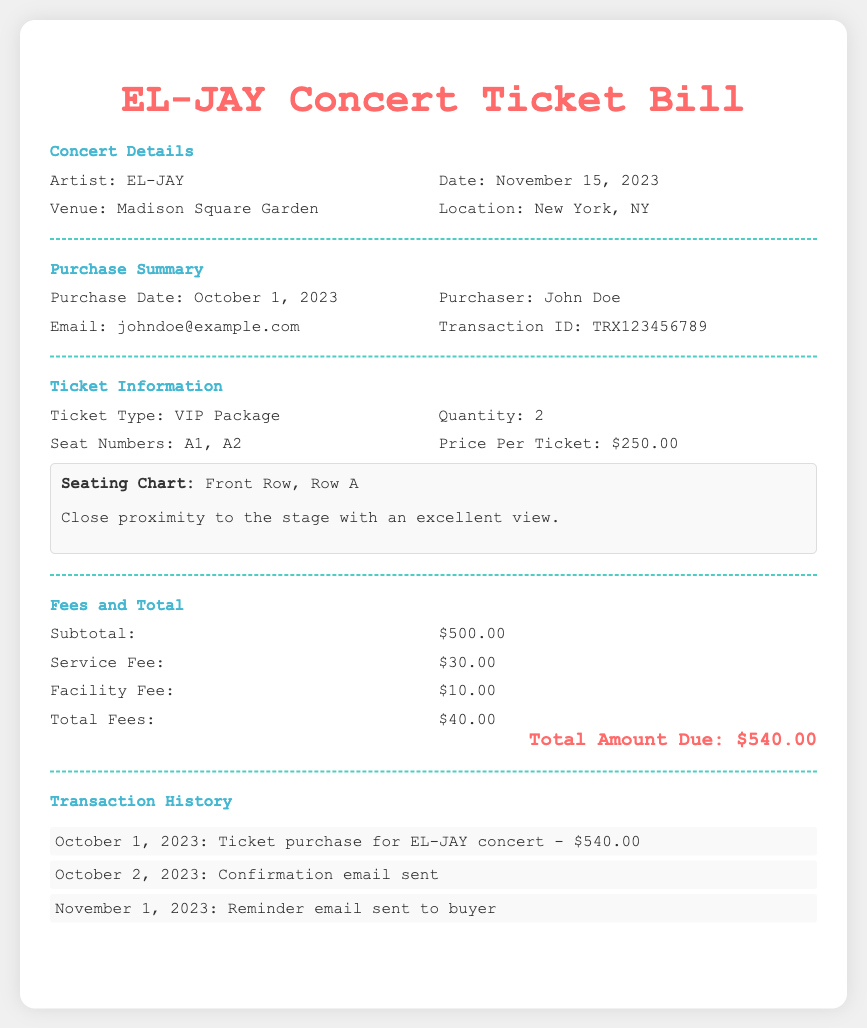What is the date of the concert? The concert date is provided in the document, which states November 15, 2023.
Answer: November 15, 2023 Who is the purchaser of the tickets? The document includes the purchaser's name as John Doe, highlighted in the Purchase Summary section.
Answer: John Doe How many tickets were purchased? The document specifies that the quantity of tickets purchased is 2 in the Ticket Information section.
Answer: 2 What is the total amount due? The total amount due is clearly listed at the bottom of the Fees and Total section, totaling $540.00.
Answer: $540.00 What are the seat numbers for the tickets? The seat numbers for the purchased tickets are listed in the Ticket Information section as A1 and A2.
Answer: A1, A2 What is the service fee included in the ticket purchase? The service fee amount is specifically mentioned in the Fees and Total section as $30.00.
Answer: $30.00 What is the transaction ID for the purchase? The transaction ID can be found in the Purchase Summary section as TRX123456789.
Answer: TRX123456789 What type of tickets were purchased? The document states the ticket type as VIP Package in the Ticket Information section.
Answer: VIP Package How much is the facility fee? The facility fee amount is provided in the Fees and Total section as $10.00.
Answer: $10.00 